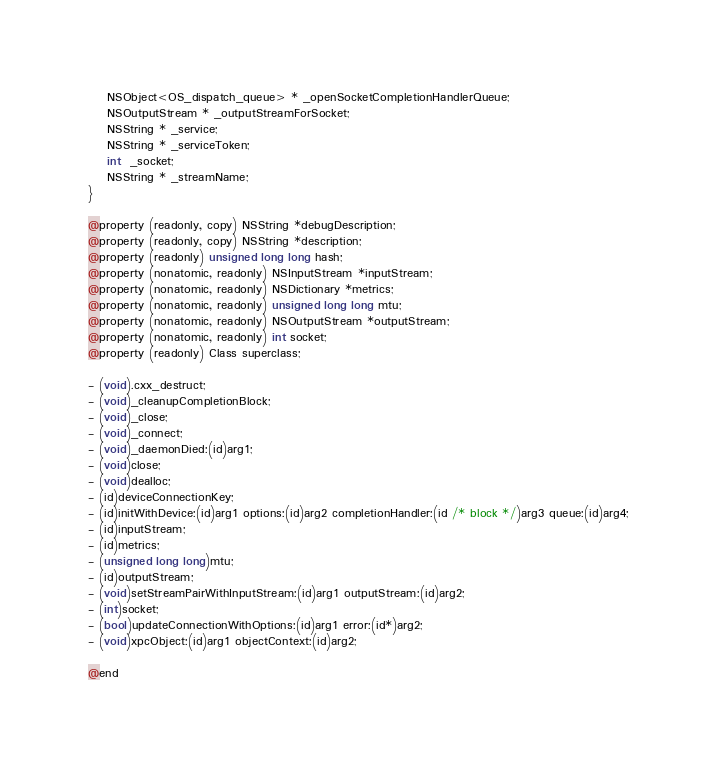Convert code to text. <code><loc_0><loc_0><loc_500><loc_500><_C_>    NSObject<OS_dispatch_queue> * _openSocketCompletionHandlerQueue;
    NSOutputStream * _outputStreamForSocket;
    NSString * _service;
    NSString * _serviceToken;
    int  _socket;
    NSString * _streamName;
}

@property (readonly, copy) NSString *debugDescription;
@property (readonly, copy) NSString *description;
@property (readonly) unsigned long long hash;
@property (nonatomic, readonly) NSInputStream *inputStream;
@property (nonatomic, readonly) NSDictionary *metrics;
@property (nonatomic, readonly) unsigned long long mtu;
@property (nonatomic, readonly) NSOutputStream *outputStream;
@property (nonatomic, readonly) int socket;
@property (readonly) Class superclass;

- (void).cxx_destruct;
- (void)_cleanupCompletionBlock;
- (void)_close;
- (void)_connect;
- (void)_daemonDied:(id)arg1;
- (void)close;
- (void)dealloc;
- (id)deviceConnectionKey;
- (id)initWithDevice:(id)arg1 options:(id)arg2 completionHandler:(id /* block */)arg3 queue:(id)arg4;
- (id)inputStream;
- (id)metrics;
- (unsigned long long)mtu;
- (id)outputStream;
- (void)setStreamPairWithInputStream:(id)arg1 outputStream:(id)arg2;
- (int)socket;
- (bool)updateConnectionWithOptions:(id)arg1 error:(id*)arg2;
- (void)xpcObject:(id)arg1 objectContext:(id)arg2;

@end
</code> 